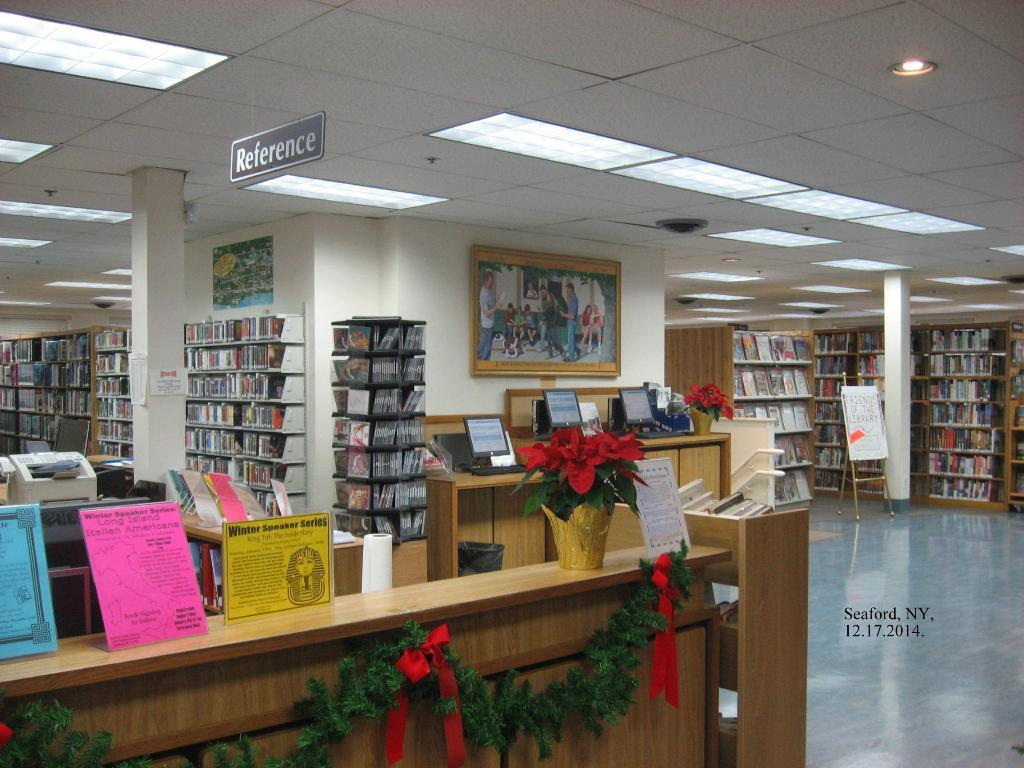Provide a one-sentence caption for the provided image. a library in Seaford NY taken on 12.17.2014. 